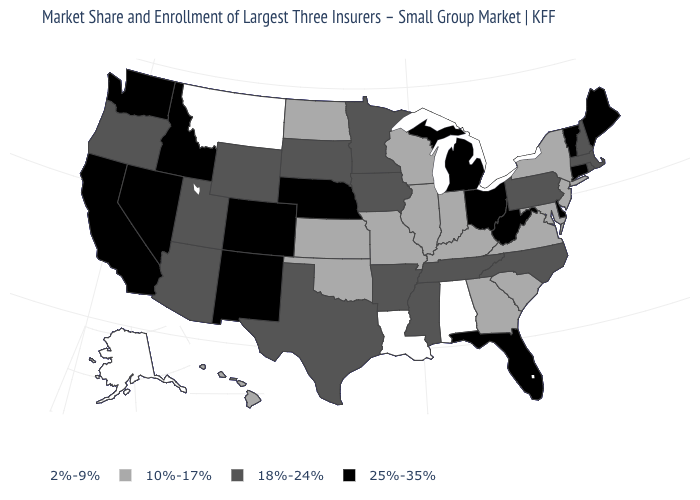What is the value of New Hampshire?
Answer briefly. 18%-24%. How many symbols are there in the legend?
Write a very short answer. 4. What is the value of Alaska?
Answer briefly. 2%-9%. How many symbols are there in the legend?
Write a very short answer. 4. Which states have the lowest value in the West?
Be succinct. Alaska, Montana. What is the highest value in states that border Nebraska?
Answer briefly. 25%-35%. Does Virginia have a lower value than Iowa?
Quick response, please. Yes. What is the value of New Hampshire?
Give a very brief answer. 18%-24%. What is the value of Iowa?
Write a very short answer. 18%-24%. Which states hav the highest value in the MidWest?
Concise answer only. Michigan, Nebraska, Ohio. What is the highest value in states that border Wyoming?
Concise answer only. 25%-35%. What is the highest value in the Northeast ?
Concise answer only. 25%-35%. Name the states that have a value in the range 2%-9%?
Short answer required. Alabama, Alaska, Louisiana, Montana. What is the value of Arizona?
Short answer required. 18%-24%. What is the value of Arkansas?
Be succinct. 18%-24%. 